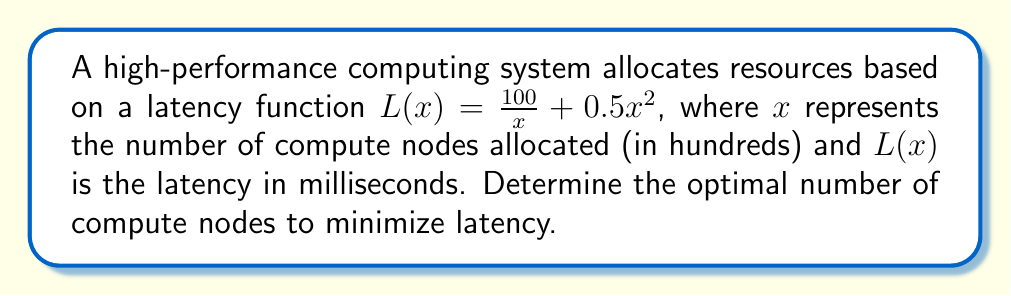Solve this math problem. To find the optimal number of compute nodes that minimizes latency, we need to find the minimum point of the latency function $L(x)$. This can be done by following these steps:

1) First, we take the derivative of $L(x)$ with respect to $x$:

   $$L'(x) = \frac{d}{dx}\left(\frac{100}{x} + 0.5x^2\right) = -\frac{100}{x^2} + x$$

2) To find the minimum point, we set $L'(x) = 0$ and solve for $x$:

   $$-\frac{100}{x^2} + x = 0$$

3) Multiply both sides by $x^2$:

   $$-100 + x^3 = 0$$

4) Rearrange the equation:

   $$x^3 = 100$$

5) Take the cube root of both sides:

   $$x = \sqrt[3]{100} \approx 4.64$$

6) To confirm this is a minimum, we can check the second derivative:

   $$L''(x) = \frac{200}{x^3} + 1$$

   At $x = \sqrt[3]{100}$, $L''(x) > 0$, confirming a minimum.

7) Since $x$ represents hundreds of compute nodes, we multiply by 100:

   Optimal number of compute nodes $\approx 464$
Answer: 464 compute nodes 